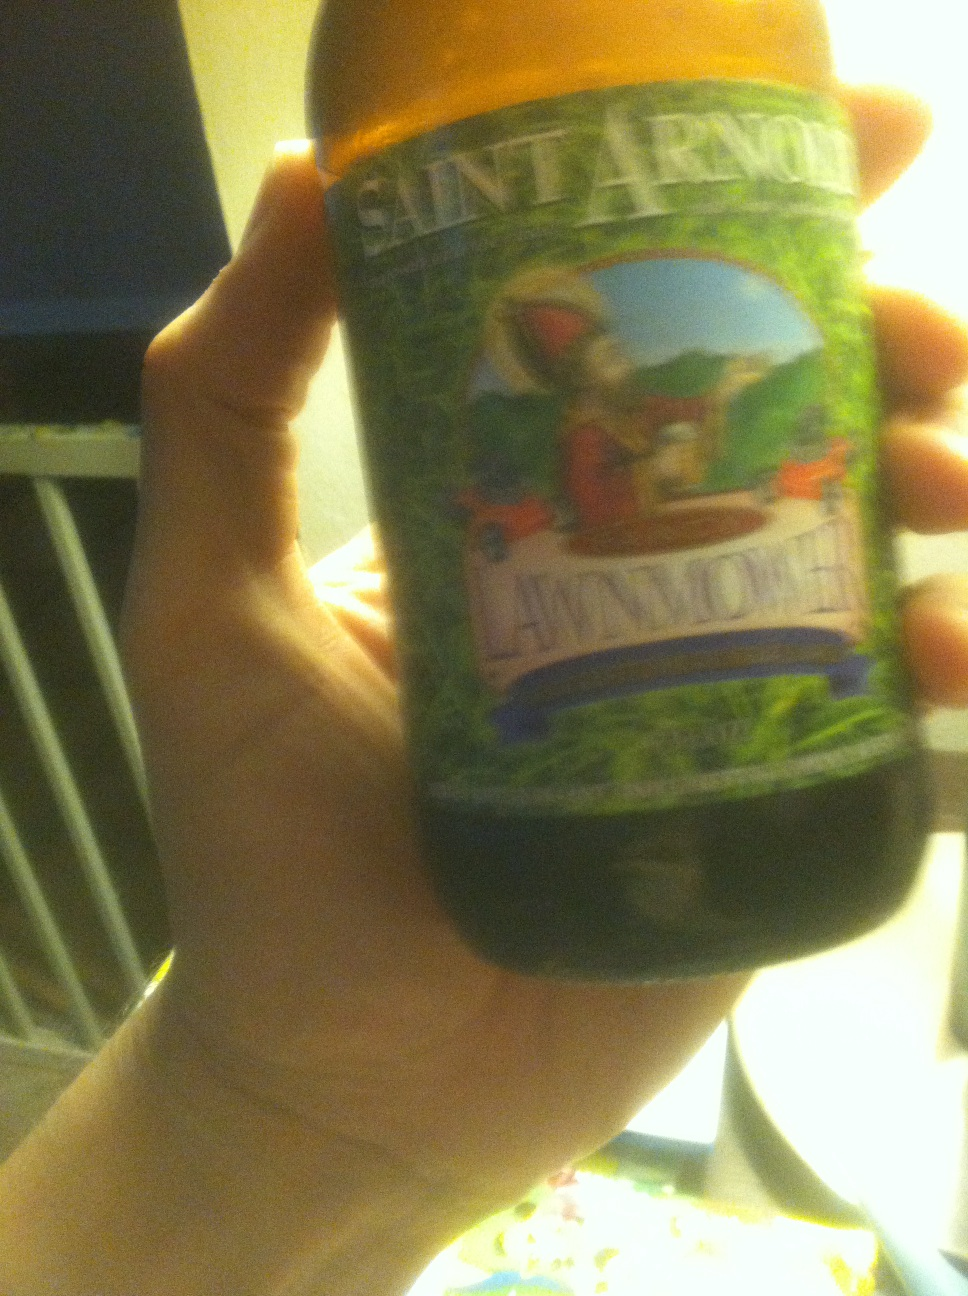What type of beer is this? The beer shown in the image is Saint Arnold's Lawnmower, a popular Kölsch-style beer known for its crisp and refreshing taste, often chosen for its lighter yet flavorful profile ideal for warm weather. 